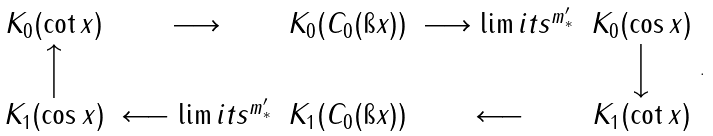<formula> <loc_0><loc_0><loc_500><loc_500>\begin{array} { c c c c c } K _ { 0 } ( \cot x ) & \longrightarrow & K _ { 0 } ( C _ { 0 } ( \i x ) ) & { \longrightarrow \lim i t s ^ { m _ { * } ^ { \prime } } } & K _ { 0 } ( \cos x ) \\ \Big \uparrow & & & & \Big \downarrow \\ K _ { 1 } ( \cos x ) & { \longleftarrow \lim i t s ^ { m _ { * } ^ { \prime } } } & K _ { 1 } ( C _ { 0 } ( \i x ) ) & \longleftarrow & K _ { 1 } ( \cot x ) \end{array} .</formula> 